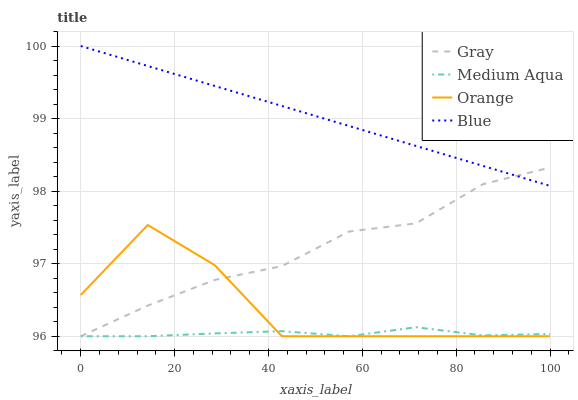Does Medium Aqua have the minimum area under the curve?
Answer yes or no. Yes. Does Blue have the maximum area under the curve?
Answer yes or no. Yes. Does Gray have the minimum area under the curve?
Answer yes or no. No. Does Gray have the maximum area under the curve?
Answer yes or no. No. Is Blue the smoothest?
Answer yes or no. Yes. Is Orange the roughest?
Answer yes or no. Yes. Is Gray the smoothest?
Answer yes or no. No. Is Gray the roughest?
Answer yes or no. No. Does Orange have the lowest value?
Answer yes or no. Yes. Does Blue have the lowest value?
Answer yes or no. No. Does Blue have the highest value?
Answer yes or no. Yes. Does Gray have the highest value?
Answer yes or no. No. Is Orange less than Blue?
Answer yes or no. Yes. Is Blue greater than Orange?
Answer yes or no. Yes. Does Gray intersect Orange?
Answer yes or no. Yes. Is Gray less than Orange?
Answer yes or no. No. Is Gray greater than Orange?
Answer yes or no. No. Does Orange intersect Blue?
Answer yes or no. No. 